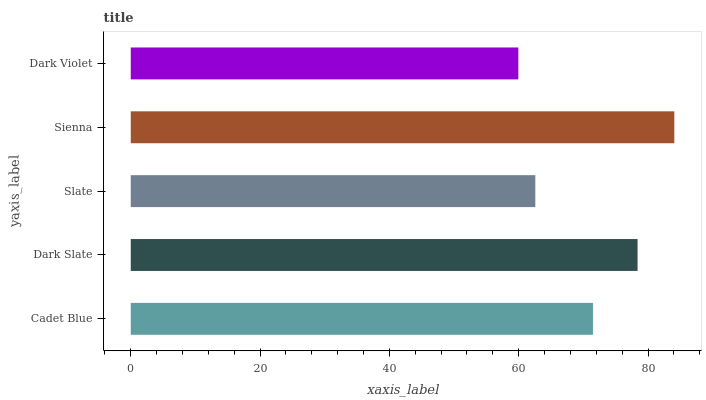Is Dark Violet the minimum?
Answer yes or no. Yes. Is Sienna the maximum?
Answer yes or no. Yes. Is Dark Slate the minimum?
Answer yes or no. No. Is Dark Slate the maximum?
Answer yes or no. No. Is Dark Slate greater than Cadet Blue?
Answer yes or no. Yes. Is Cadet Blue less than Dark Slate?
Answer yes or no. Yes. Is Cadet Blue greater than Dark Slate?
Answer yes or no. No. Is Dark Slate less than Cadet Blue?
Answer yes or no. No. Is Cadet Blue the high median?
Answer yes or no. Yes. Is Cadet Blue the low median?
Answer yes or no. Yes. Is Dark Slate the high median?
Answer yes or no. No. Is Slate the low median?
Answer yes or no. No. 